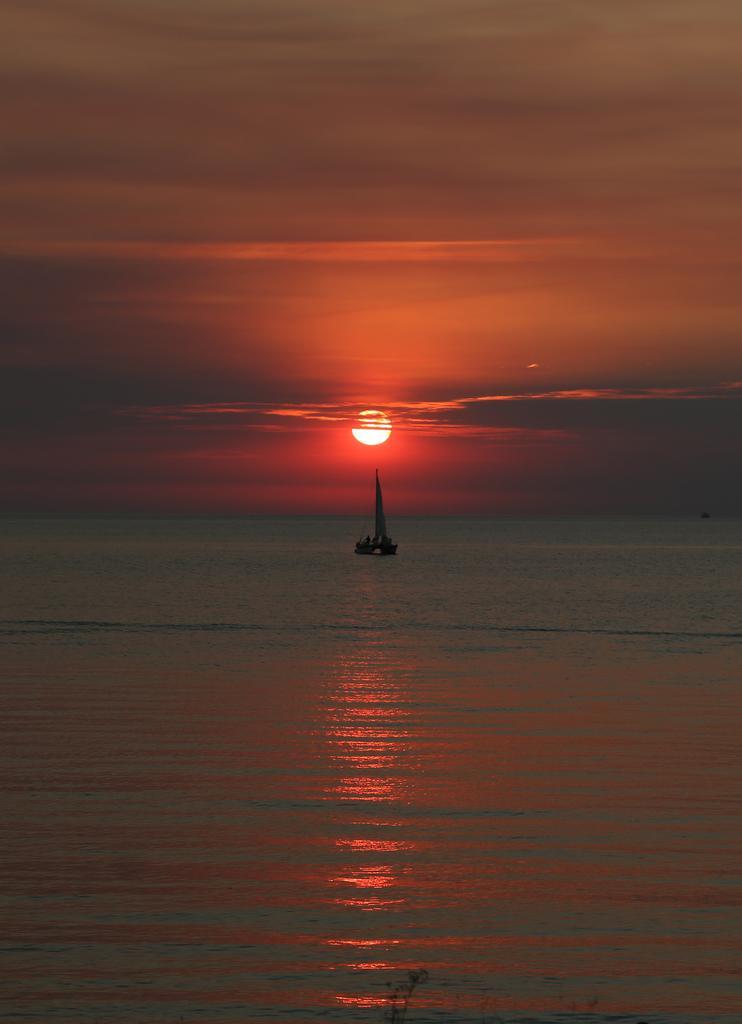Describe this image in one or two sentences. Here we can see a boat on the water. In the background there are clouds in the sky and a sun. 